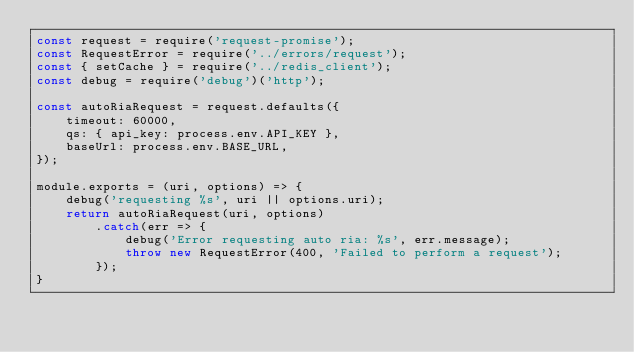Convert code to text. <code><loc_0><loc_0><loc_500><loc_500><_JavaScript_>const request = require('request-promise');
const RequestError = require('../errors/request');
const { setCache } = require('../redis_client');
const debug = require('debug')('http');

const autoRiaRequest = request.defaults({
	timeout: 60000,
	qs: { api_key: process.env.API_KEY },
	baseUrl: process.env.BASE_URL,
});

module.exports = (uri, options) => {
	debug('requesting %s', uri || options.uri);
	return autoRiaRequest(uri, options)
		.catch(err => {
			debug('Error requesting auto ria: %s', err.message);
			throw new RequestError(400, 'Failed to perform a request');
		});
}
</code> 